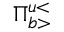<formula> <loc_0><loc_0><loc_500><loc_500>\Pi _ { b > } ^ { u < }</formula> 